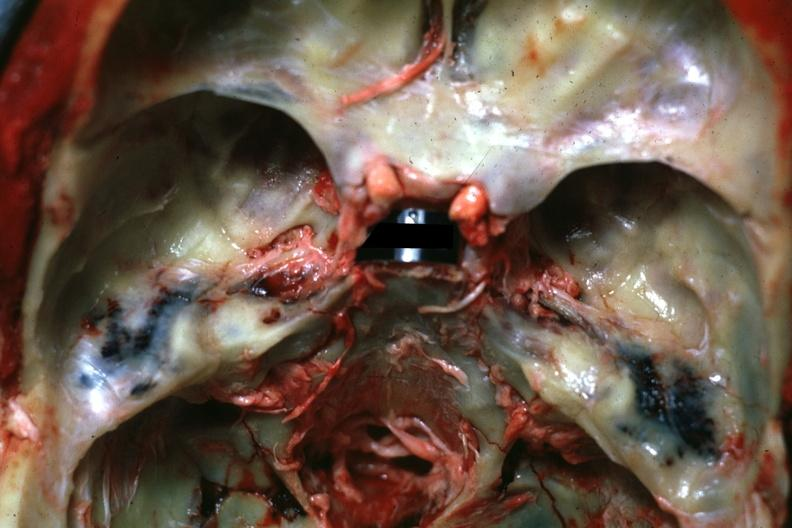how does this image show view of middle ear areas?
Answer the question using a single word or phrase. With obvious hemorrhage in under-lying tissue 